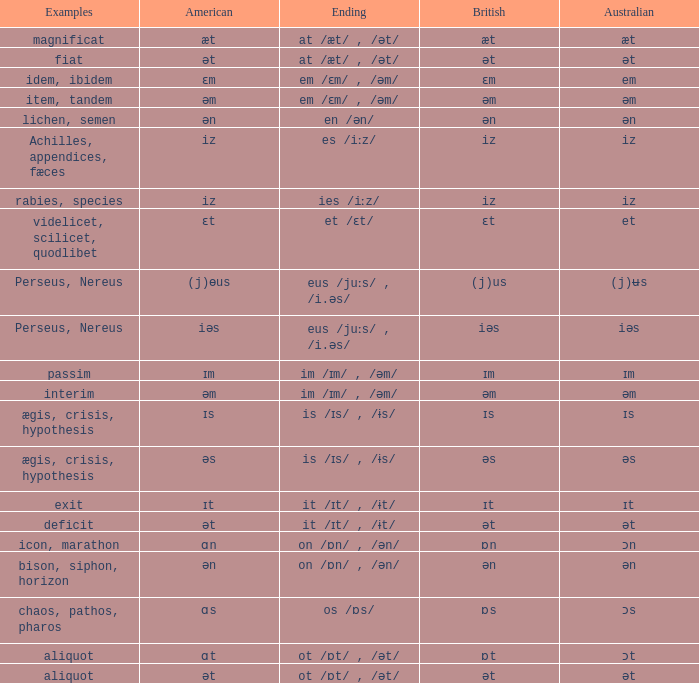Which American has British of ɛm? Ɛm. 